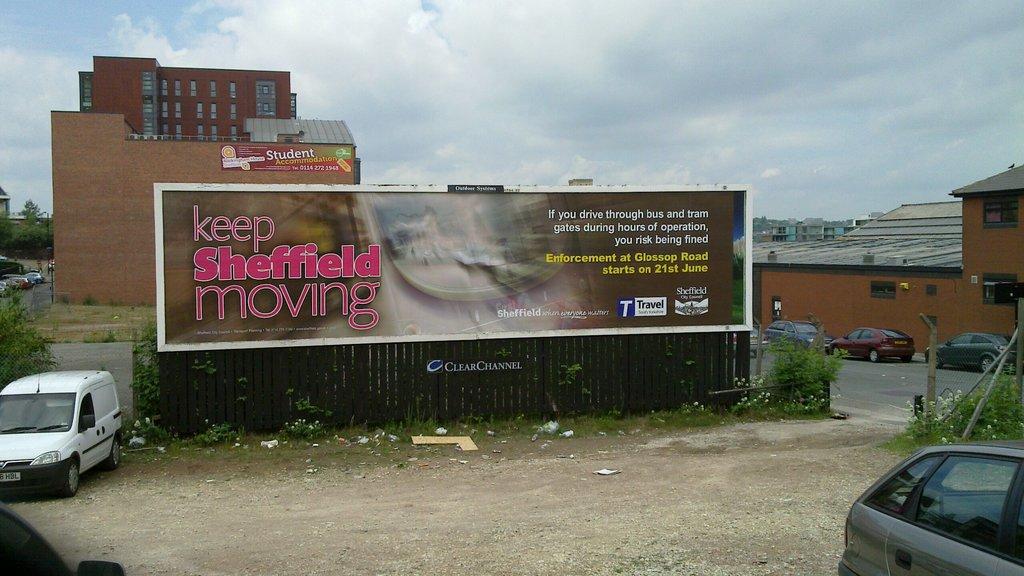What town is this?
Offer a terse response. Sheffield. Keep sheffield what?
Give a very brief answer. Moving. 